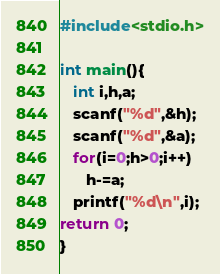Convert code to text. <code><loc_0><loc_0><loc_500><loc_500><_C_>#include<stdio.h>

int main(){
   int i,h,a;
   scanf("%d",&h);
   scanf("%d",&a);
   for(i=0;h>0;i++)
      h-=a;
   printf("%d\n",i);
return 0;
}
</code> 